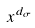<formula> <loc_0><loc_0><loc_500><loc_500>x ^ { d _ { \sigma } }</formula> 